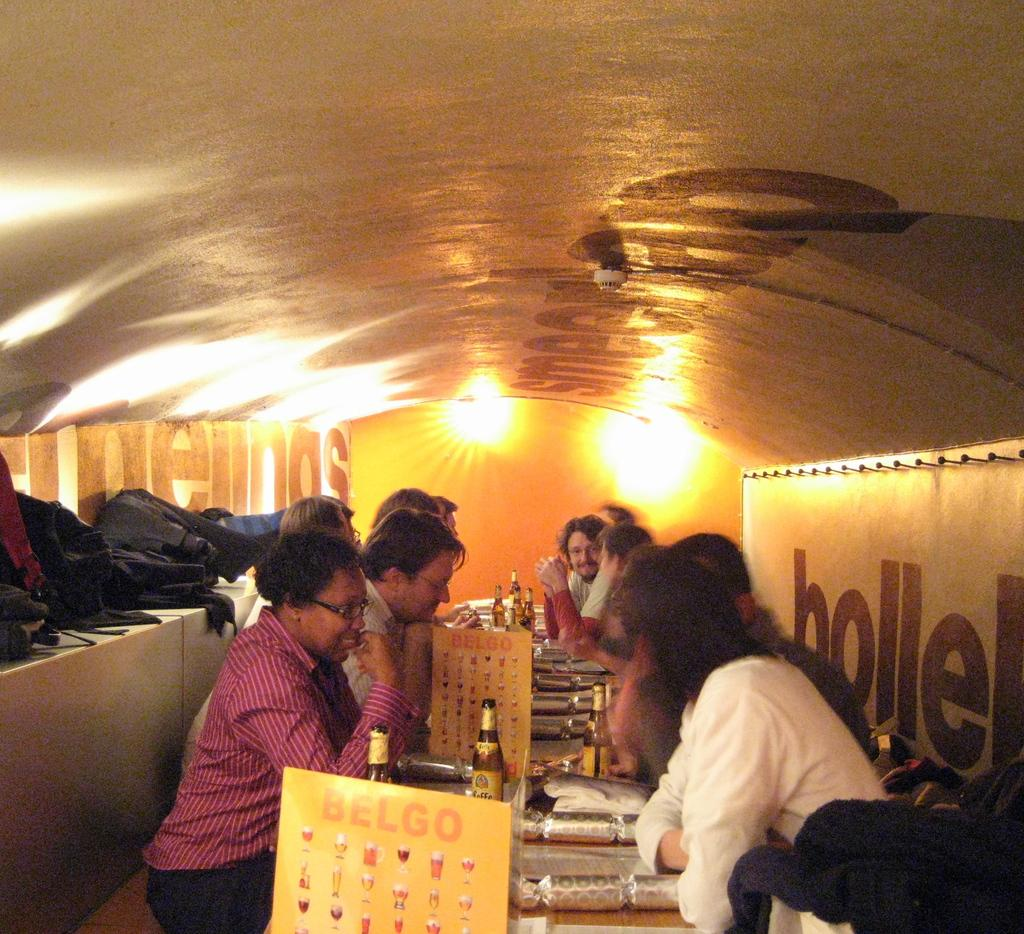How many people are in the image? There is a group of people in the image. What are the people in the image doing? The people are sitting. What else can be seen in the image besides the people? There are food items, bottles, and baggage in the image. What type of scene is being blown in the image? There is no scene being blown in the image. 